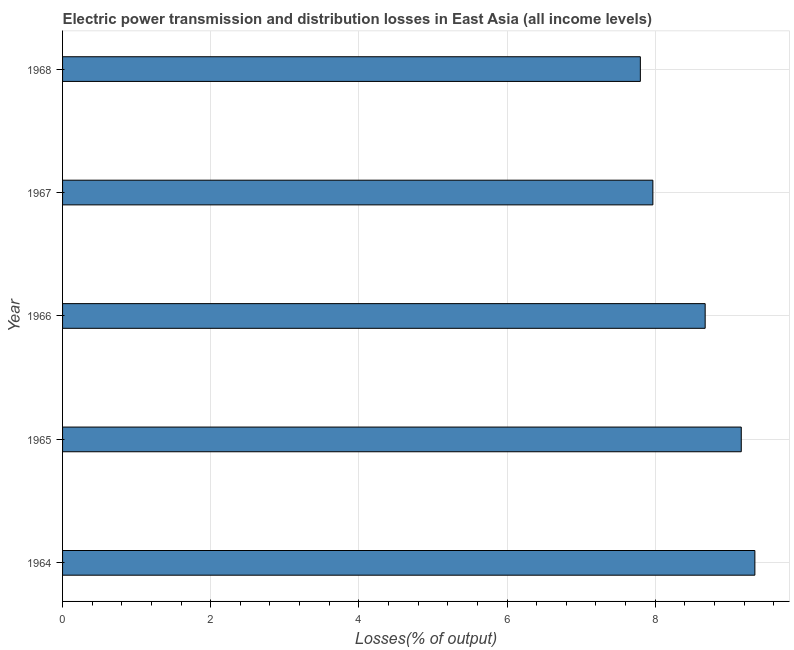Does the graph contain grids?
Your response must be concise. Yes. What is the title of the graph?
Ensure brevity in your answer.  Electric power transmission and distribution losses in East Asia (all income levels). What is the label or title of the X-axis?
Your response must be concise. Losses(% of output). What is the label or title of the Y-axis?
Ensure brevity in your answer.  Year. What is the electric power transmission and distribution losses in 1965?
Give a very brief answer. 9.16. Across all years, what is the maximum electric power transmission and distribution losses?
Your answer should be very brief. 9.35. Across all years, what is the minimum electric power transmission and distribution losses?
Provide a short and direct response. 7.8. In which year was the electric power transmission and distribution losses maximum?
Ensure brevity in your answer.  1964. In which year was the electric power transmission and distribution losses minimum?
Your answer should be very brief. 1968. What is the sum of the electric power transmission and distribution losses?
Your answer should be compact. 42.95. What is the difference between the electric power transmission and distribution losses in 1967 and 1968?
Your response must be concise. 0.17. What is the average electric power transmission and distribution losses per year?
Your answer should be very brief. 8.59. What is the median electric power transmission and distribution losses?
Offer a very short reply. 8.67. What is the ratio of the electric power transmission and distribution losses in 1965 to that in 1966?
Give a very brief answer. 1.06. What is the difference between the highest and the second highest electric power transmission and distribution losses?
Keep it short and to the point. 0.18. What is the difference between the highest and the lowest electric power transmission and distribution losses?
Your answer should be very brief. 1.55. In how many years, is the electric power transmission and distribution losses greater than the average electric power transmission and distribution losses taken over all years?
Offer a very short reply. 3. How many bars are there?
Ensure brevity in your answer.  5. Are all the bars in the graph horizontal?
Provide a short and direct response. Yes. What is the difference between two consecutive major ticks on the X-axis?
Offer a very short reply. 2. Are the values on the major ticks of X-axis written in scientific E-notation?
Your answer should be compact. No. What is the Losses(% of output) in 1964?
Provide a succinct answer. 9.35. What is the Losses(% of output) of 1965?
Your answer should be very brief. 9.16. What is the Losses(% of output) in 1966?
Provide a succinct answer. 8.67. What is the Losses(% of output) of 1967?
Your answer should be compact. 7.97. What is the Losses(% of output) in 1968?
Give a very brief answer. 7.8. What is the difference between the Losses(% of output) in 1964 and 1965?
Your answer should be compact. 0.18. What is the difference between the Losses(% of output) in 1964 and 1966?
Your response must be concise. 0.67. What is the difference between the Losses(% of output) in 1964 and 1967?
Ensure brevity in your answer.  1.38. What is the difference between the Losses(% of output) in 1964 and 1968?
Provide a short and direct response. 1.55. What is the difference between the Losses(% of output) in 1965 and 1966?
Give a very brief answer. 0.49. What is the difference between the Losses(% of output) in 1965 and 1967?
Give a very brief answer. 1.19. What is the difference between the Losses(% of output) in 1965 and 1968?
Offer a terse response. 1.36. What is the difference between the Losses(% of output) in 1966 and 1967?
Give a very brief answer. 0.71. What is the difference between the Losses(% of output) in 1966 and 1968?
Provide a succinct answer. 0.87. What is the difference between the Losses(% of output) in 1967 and 1968?
Offer a terse response. 0.17. What is the ratio of the Losses(% of output) in 1964 to that in 1966?
Your answer should be very brief. 1.08. What is the ratio of the Losses(% of output) in 1964 to that in 1967?
Your answer should be very brief. 1.17. What is the ratio of the Losses(% of output) in 1964 to that in 1968?
Make the answer very short. 1.2. What is the ratio of the Losses(% of output) in 1965 to that in 1966?
Provide a short and direct response. 1.06. What is the ratio of the Losses(% of output) in 1965 to that in 1967?
Your answer should be compact. 1.15. What is the ratio of the Losses(% of output) in 1965 to that in 1968?
Ensure brevity in your answer.  1.18. What is the ratio of the Losses(% of output) in 1966 to that in 1967?
Provide a short and direct response. 1.09. What is the ratio of the Losses(% of output) in 1966 to that in 1968?
Keep it short and to the point. 1.11. What is the ratio of the Losses(% of output) in 1967 to that in 1968?
Provide a succinct answer. 1.02. 